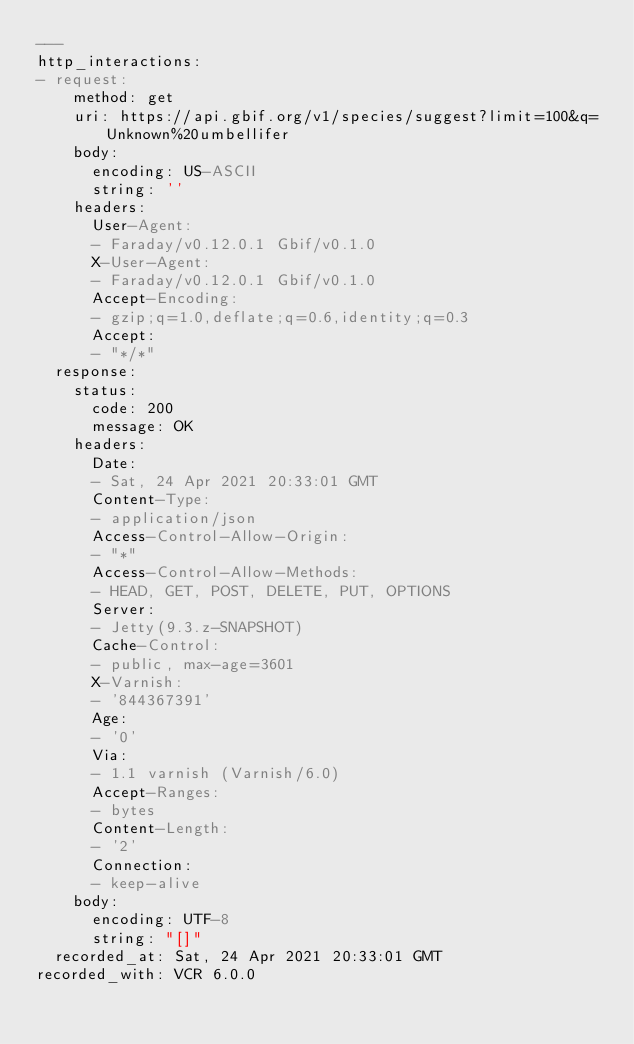Convert code to text. <code><loc_0><loc_0><loc_500><loc_500><_YAML_>---
http_interactions:
- request:
    method: get
    uri: https://api.gbif.org/v1/species/suggest?limit=100&q=Unknown%20umbellifer
    body:
      encoding: US-ASCII
      string: ''
    headers:
      User-Agent:
      - Faraday/v0.12.0.1 Gbif/v0.1.0
      X-User-Agent:
      - Faraday/v0.12.0.1 Gbif/v0.1.0
      Accept-Encoding:
      - gzip;q=1.0,deflate;q=0.6,identity;q=0.3
      Accept:
      - "*/*"
  response:
    status:
      code: 200
      message: OK
    headers:
      Date:
      - Sat, 24 Apr 2021 20:33:01 GMT
      Content-Type:
      - application/json
      Access-Control-Allow-Origin:
      - "*"
      Access-Control-Allow-Methods:
      - HEAD, GET, POST, DELETE, PUT, OPTIONS
      Server:
      - Jetty(9.3.z-SNAPSHOT)
      Cache-Control:
      - public, max-age=3601
      X-Varnish:
      - '844367391'
      Age:
      - '0'
      Via:
      - 1.1 varnish (Varnish/6.0)
      Accept-Ranges:
      - bytes
      Content-Length:
      - '2'
      Connection:
      - keep-alive
    body:
      encoding: UTF-8
      string: "[]"
  recorded_at: Sat, 24 Apr 2021 20:33:01 GMT
recorded_with: VCR 6.0.0
</code> 